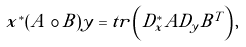<formula> <loc_0><loc_0><loc_500><loc_500>x ^ { * } ( A \circ B ) y = t r \left ( D _ { x } ^ { * } A D _ { y } B ^ { T } \right ) ,</formula> 